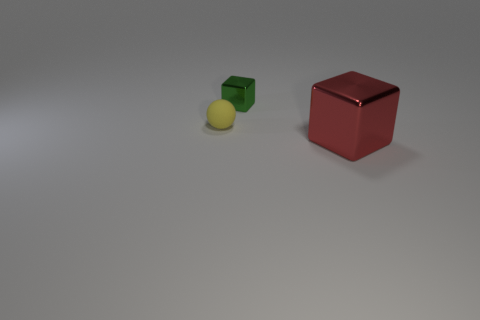What shape is not represented by the objects in the image? Among common geometric shapes, a cylinder is not represented by any of the objects in the image. 